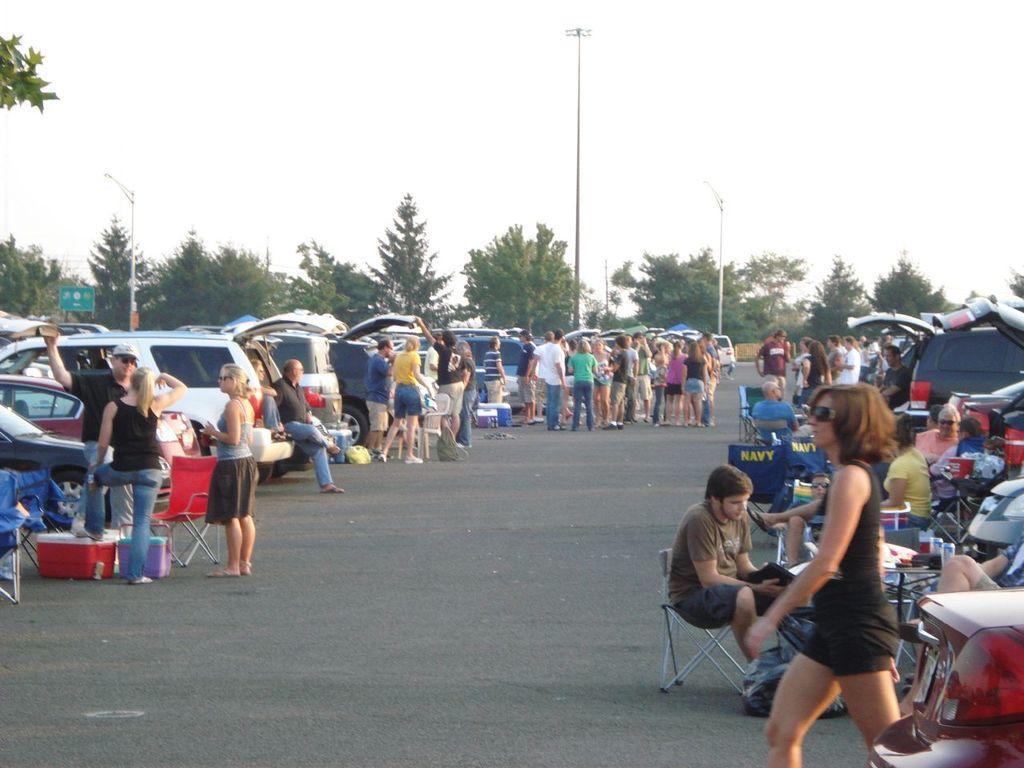Describe this image in one or two sentences. In this image I can see people were few of them are sitting on chairs and rest all are standing. I can also see number of vehicles, trees, a sign board and few polls. Here I can see few containers. 